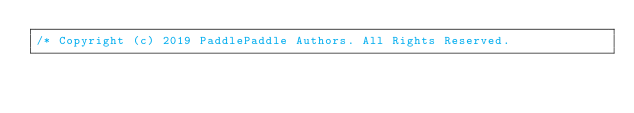<code> <loc_0><loc_0><loc_500><loc_500><_Cuda_>/* Copyright (c) 2019 PaddlePaddle Authors. All Rights Reserved.</code> 